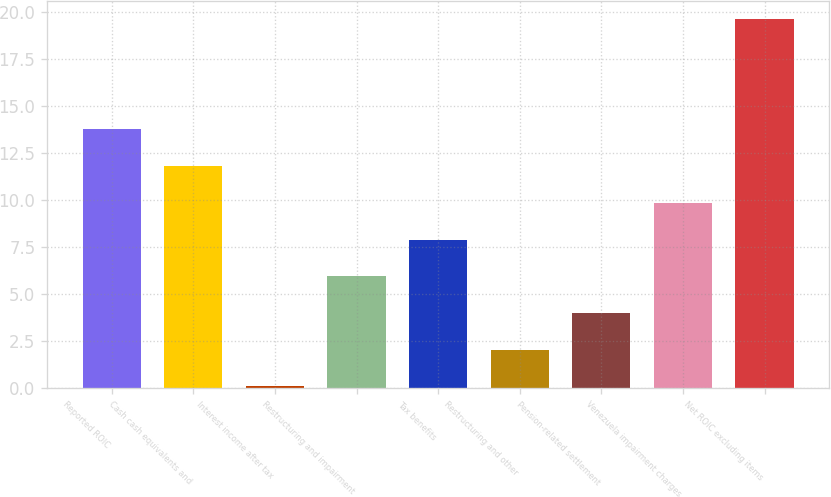Convert chart to OTSL. <chart><loc_0><loc_0><loc_500><loc_500><bar_chart><fcel>Reported ROIC<fcel>Cash cash equivalents and<fcel>Interest income after tax<fcel>Restructuring and impairment<fcel>Tax benefits<fcel>Restructuring and other<fcel>Pension-related settlement<fcel>Venezuela impairment charges<fcel>Net ROIC excluding items<nl><fcel>13.75<fcel>11.8<fcel>0.1<fcel>5.95<fcel>7.9<fcel>2.05<fcel>4<fcel>9.85<fcel>19.6<nl></chart> 